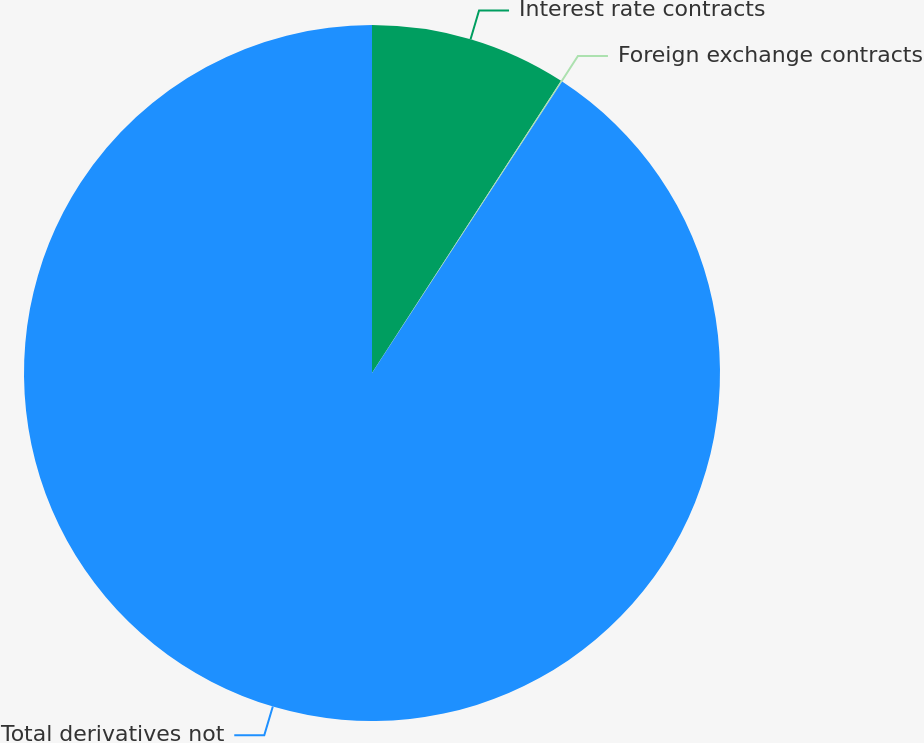Convert chart. <chart><loc_0><loc_0><loc_500><loc_500><pie_chart><fcel>Interest rate contracts<fcel>Foreign exchange contracts<fcel>Total derivatives not<nl><fcel>9.14%<fcel>0.06%<fcel>90.8%<nl></chart> 